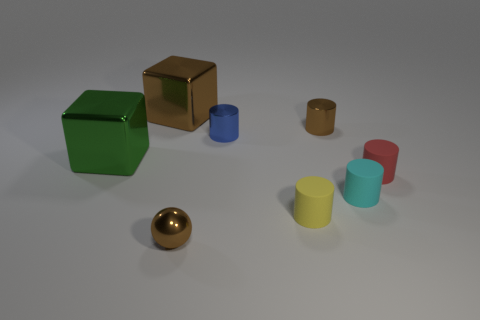There is a cube that is the same color as the small shiny sphere; what is its size?
Provide a succinct answer. Large. The red object that is the same material as the tiny yellow object is what shape?
Your response must be concise. Cylinder. Do the thing that is in front of the tiny yellow rubber object and the brown thing that is on the right side of the metallic sphere have the same size?
Ensure brevity in your answer.  Yes. There is a shiny object that is in front of the cyan thing; what is its color?
Make the answer very short. Brown. There is a tiny cylinder left of the yellow cylinder in front of the big green metal object; what is its material?
Offer a terse response. Metal. What is the shape of the large brown object?
Keep it short and to the point. Cube. There is a tiny brown object that is the same shape as the small red matte thing; what is its material?
Your response must be concise. Metal. What number of blue metallic cylinders are the same size as the cyan thing?
Offer a very short reply. 1. There is a metal object in front of the tiny yellow thing; are there any tiny blue metallic objects that are left of it?
Your answer should be very brief. No. What number of cyan objects are either matte cylinders or cylinders?
Your response must be concise. 1. 